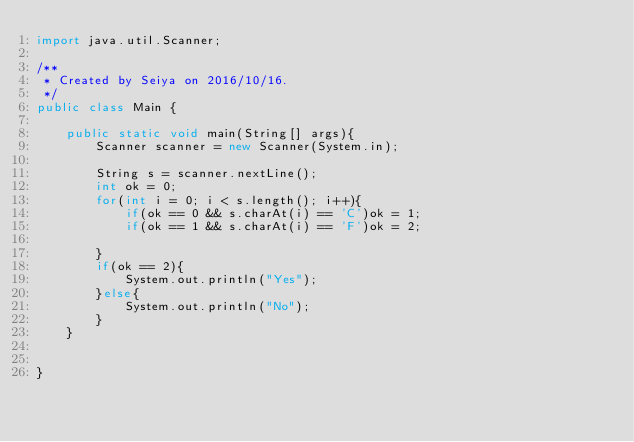<code> <loc_0><loc_0><loc_500><loc_500><_Java_>import java.util.Scanner;

/**
 * Created by Seiya on 2016/10/16.
 */
public class Main {

    public static void main(String[] args){
        Scanner scanner = new Scanner(System.in);

        String s = scanner.nextLine();
        int ok = 0;
        for(int i = 0; i < s.length(); i++){
            if(ok == 0 && s.charAt(i) == 'C')ok = 1;
            if(ok == 1 && s.charAt(i) == 'F')ok = 2;

        }
        if(ok == 2){
            System.out.println("Yes");
        }else{
            System.out.println("No");
        }
    }


}
</code> 